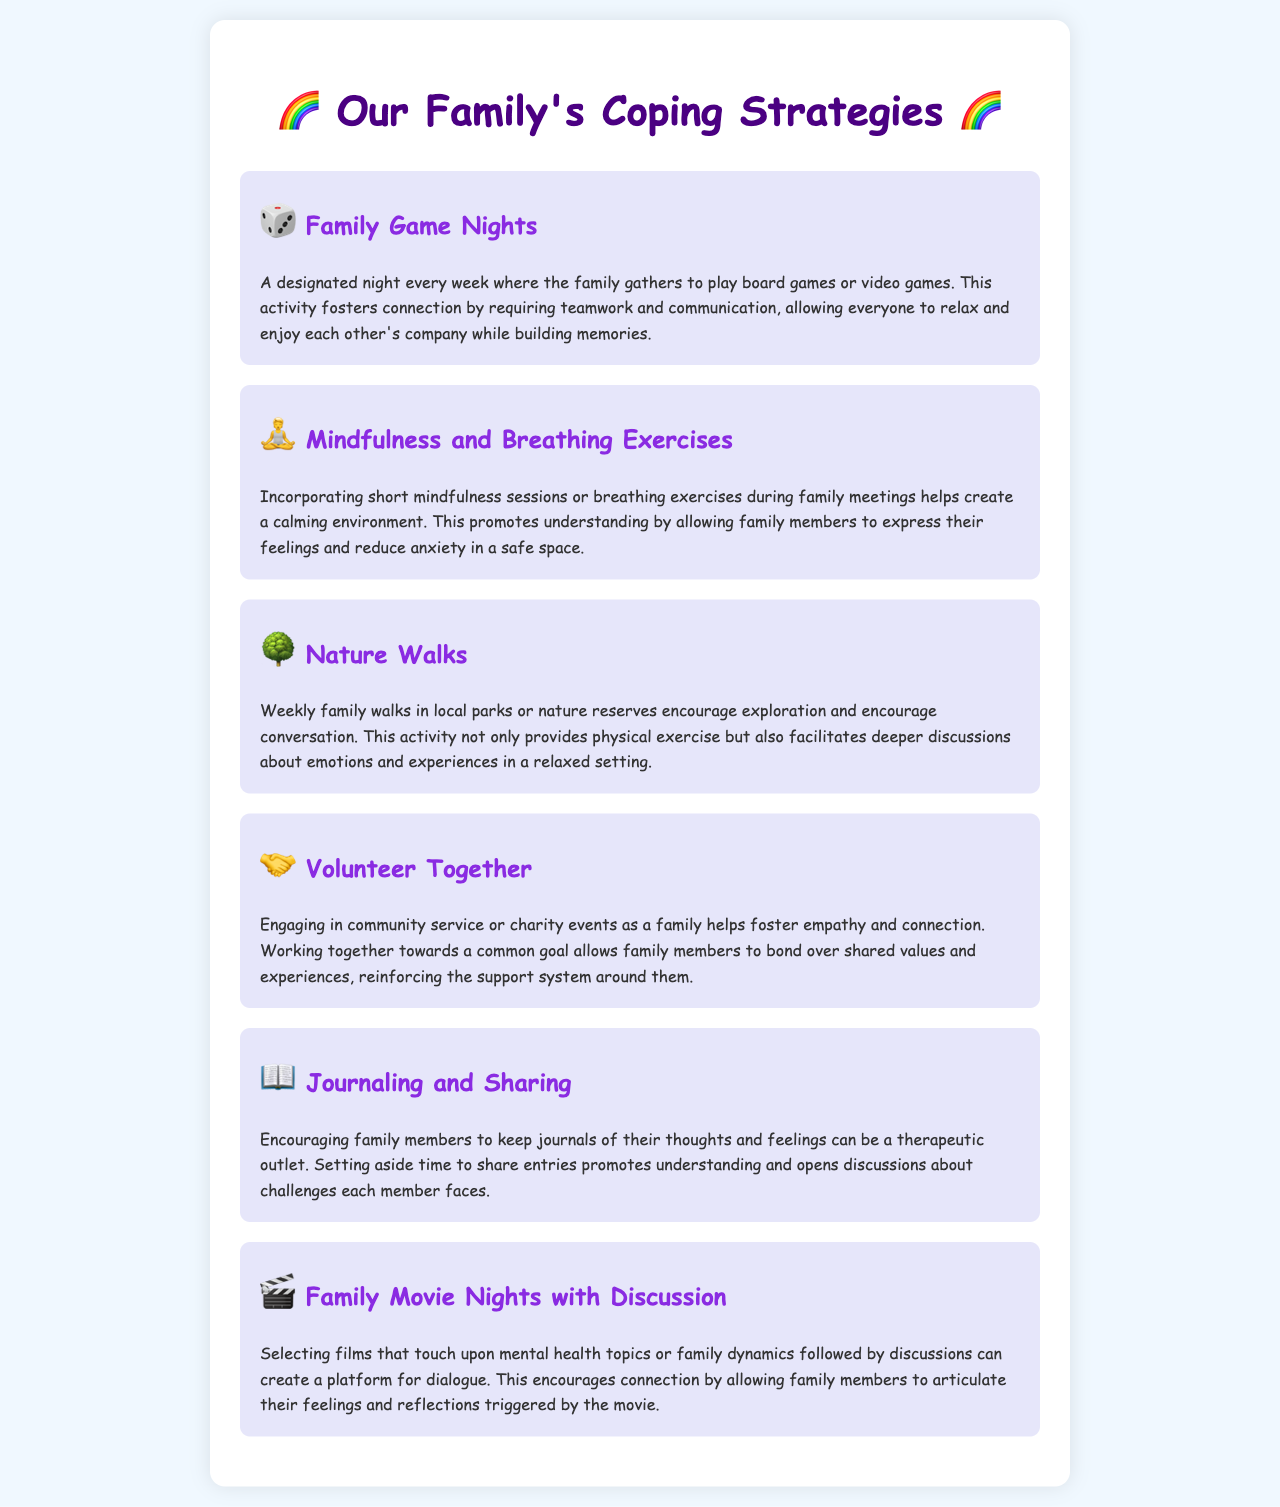What is the first coping strategy listed? The first coping strategy mentioned in the document is Family Game Nights, which involves gathering to play games.
Answer: Family Game Nights How often are Family Game Nights held? The document specifies that Family Game Nights are held once a week.
Answer: Weekly What activity encourages exploration and conversation? The document states that nature walks provide an opportunity for exploration and facilitate deeper discussions.
Answer: Nature Walks What is the purpose of volunteering together? Volunteering together aims to foster empathy and connect family members over shared values and experiences.
Answer: Empathy and connection What helps create a calming environment during family meetings? The implementation of mindfulness and breathing exercises during family meetings is what fosters a calming environment.
Answer: Mindfulness and Breathing Exercises Which coping strategy includes discussing films? Family Movie Nights with Discussion is the strategy that involves watching films and discussing them afterwards.
Answer: Family Movie Nights with Discussion 